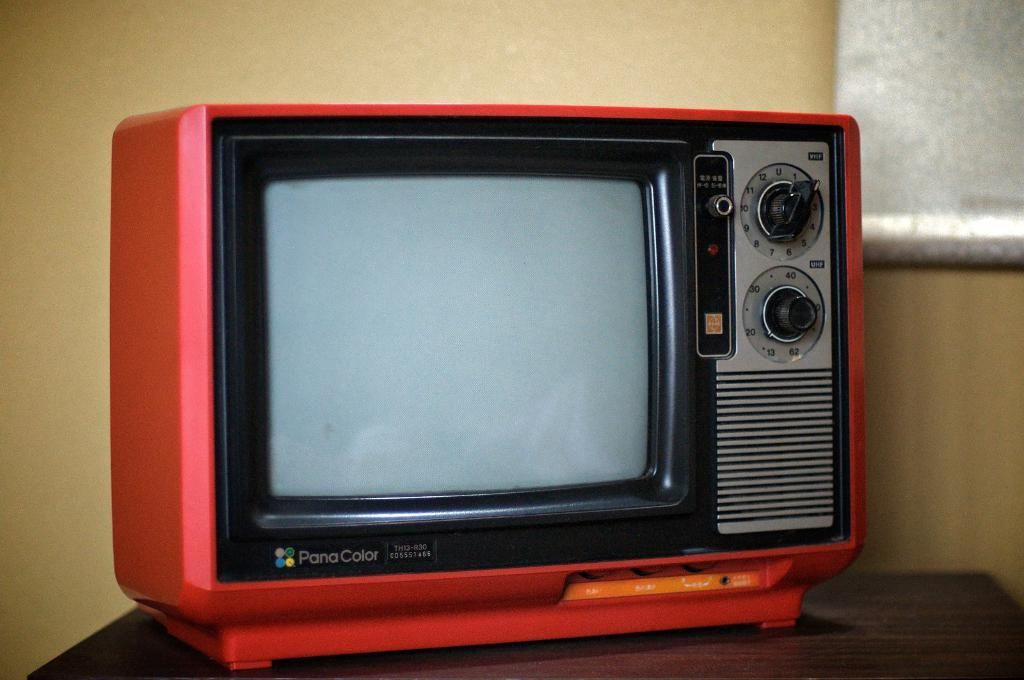<image>
Share a concise interpretation of the image provided. The old red TV has PanaColor as a feature to it. 